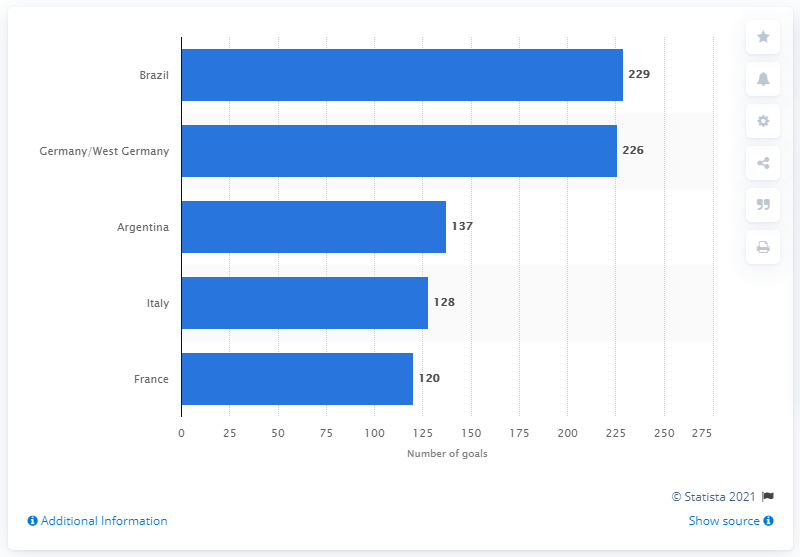How many goals did Brazil score at the 2018 FIFA World Cup? Brazil scored a total of 8 goals during the 2018 FIFA World Cup. The number 229 in the image likely refers to the total number of goals scored by Brazil across all World Cup tournaments they have participated in up to the year the data was compiled, rather than specifically in the 2018 tournament. 